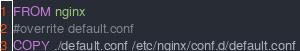Convert code to text. <code><loc_0><loc_0><loc_500><loc_500><_Dockerfile_>FROM nginx
#overrite default.conf
COPY ./default.conf /etc/nginx/conf.d/default.conf </code> 